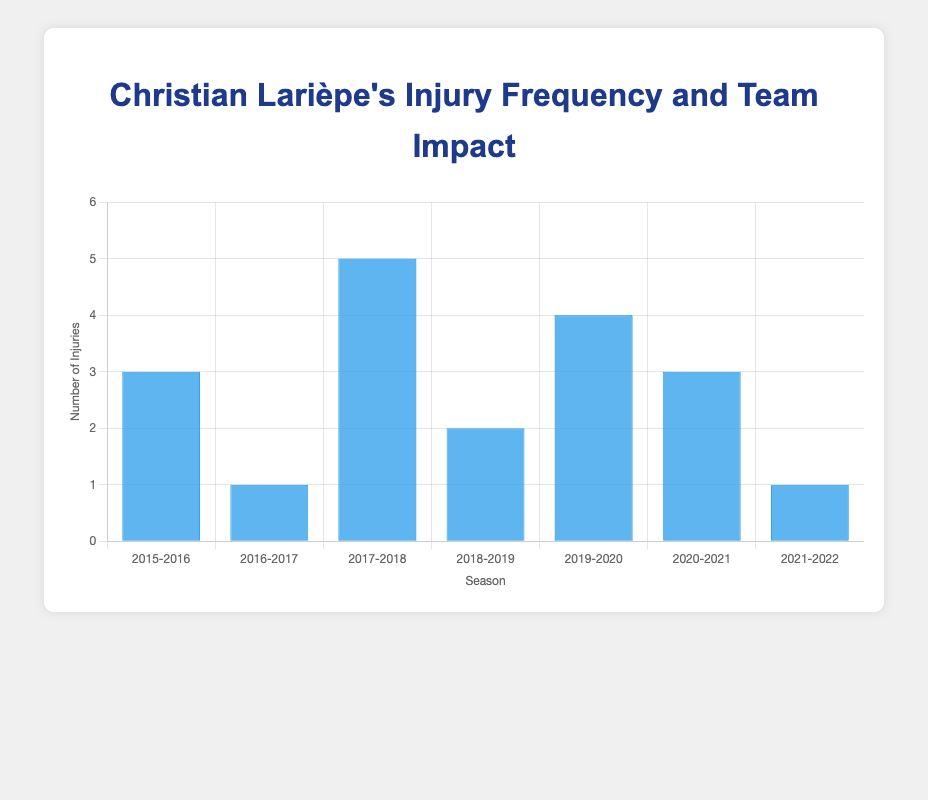Who had the most injuries in a single season? Look for the bar with the greatest height in the chart. The season 2017-2018 for FC Sochaux-Montbéliard has the highest bar with 5 injuries.
Answer: 2017-2018 How many total injuries did Christian Larièpe have over the 7 seasons? Add the numbers for injuries from each season: 3 + 1 + 5 + 2 + 4 + 3 + 1 = 19.
Answer: 19 In which season did Larièpe play the most games? Refer to the tooltip information for each bar. The 2016-2017 season with AS Nancy Lorraine shows 34 games played.
Answer: 2016-2017 Did Christian Larièpe's presence usually result in a better team position compared to when he was absent? Compare the 'team_position_with_lariepe' and 'team_position_without_lariepe' values for each season. Larièpe's presence resulted in a better position in 5 out of 7 seasons.
Answer: Yes What is the average number of injuries per season? Sum the injuries over the seasons (3 + 1 + 5 + 2 + 4 + 3 + 1 = 19) and then divide by the number of seasons (19 / 7 ≈ 2.71).
Answer: 2.71 How did the injury frequency change from the 2015-2016 season to the 2016-2017 season? Compare the height of the bars for the two seasons. The 2015-2016 bar has 3 injuries, and 2016-2017 has 1, indicating a decrease by 2 injuries.
Answer: Decreased In which season did Christian Larièpe's team have the biggest improvement in position with him playing compared to when he wasn't? Review the differences between 'team_position_with_lariepe' and 'team_position_without_lariepe'. The 2017-2018 season shows the biggest improvement from 14 to 10, which is a difference of 4 positions.
Answer: 2017-2018 Which team's performance was least impacted by Larièpe's injuries? Check the 'team_position_with_lariepe' and 'team_position_without_lariepe' values for the smallest difference. The 2016-2017 season with AS Nancy Lorraine had the same position, showing no impact.
Answer: AS Nancy Lorraine (2016-2017) How did the total number of games in the 2019-2020 season affect Larièpe's injury frequency? Notice the bar height and tooltip. The 2019-2020 season had fewer total games (28) and 4 injuries, suggesting a significant frequency relative to fewer games available.
Answer: High frequency 